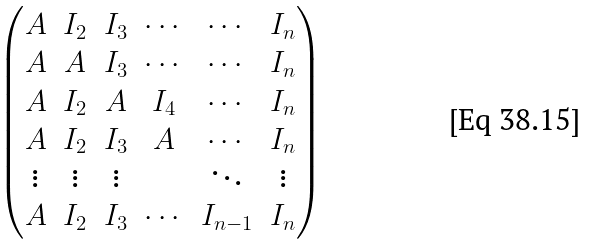Convert formula to latex. <formula><loc_0><loc_0><loc_500><loc_500>\begin{pmatrix} A & I _ { 2 } & I _ { 3 } & \cdots & \cdots & I _ { n } \\ A & A & I _ { 3 } & \cdots & \cdots & I _ { n } \\ A & I _ { 2 } & A & I _ { 4 } & \cdots & I _ { n } \\ A & I _ { 2 } & I _ { 3 } & A & \cdots & I _ { n } \\ \vdots & \vdots & \vdots & & \ddots & \vdots \\ A & I _ { 2 } & I _ { 3 } & \cdots & I _ { n - 1 } & I _ { n } \end{pmatrix}</formula> 